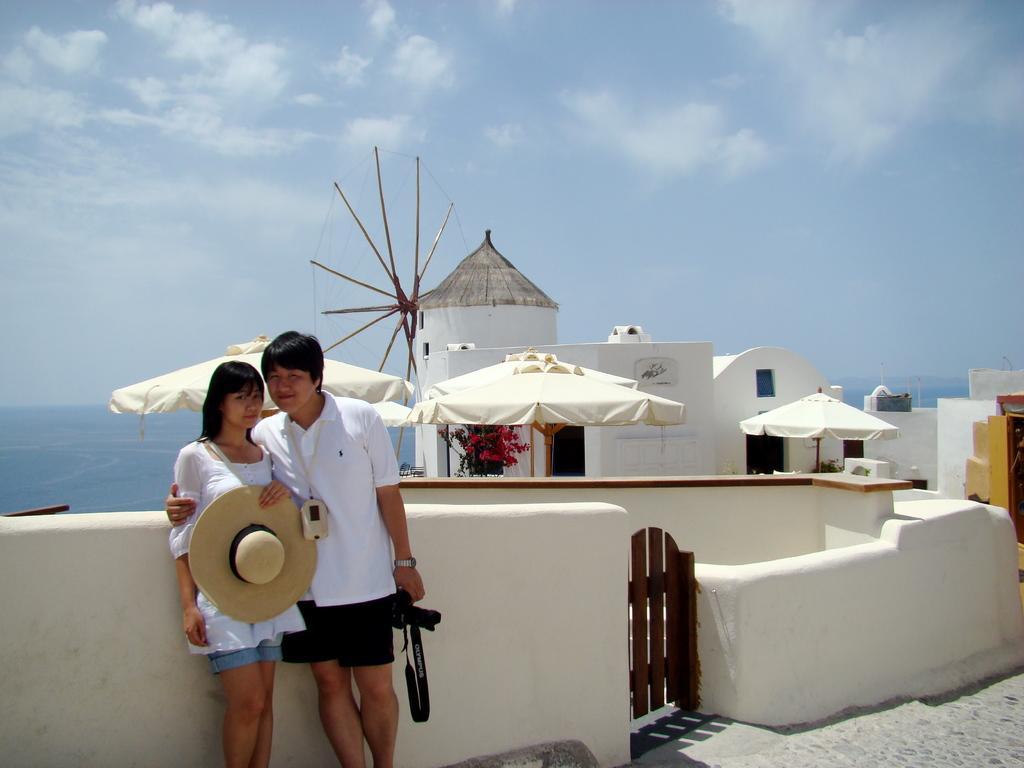How would you summarize this image in a sentence or two? In this image I can see two people with white, black and blue color dresses. I can see one person holding the hat and an another person holding the black color object. In the background I can the tents, buildings and the plant. I can see the water and the sky in the back. 